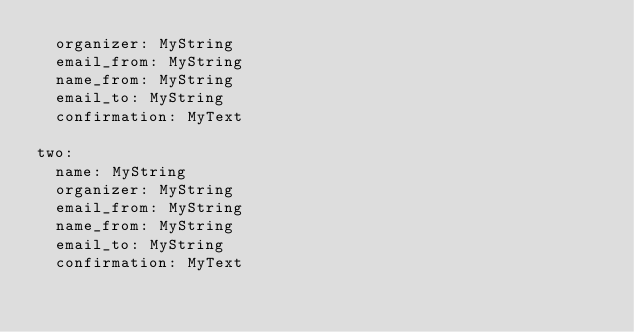Convert code to text. <code><loc_0><loc_0><loc_500><loc_500><_YAML_>  organizer: MyString
  email_from: MyString
  name_from: MyString
  email_to: MyString
  confirmation: MyText

two:
  name: MyString
  organizer: MyString
  email_from: MyString
  name_from: MyString
  email_to: MyString
  confirmation: MyText
</code> 